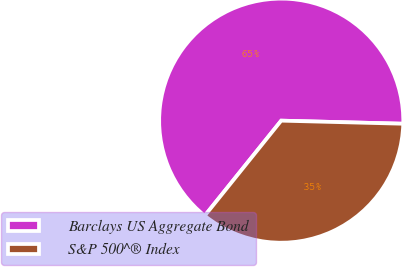Convert chart to OTSL. <chart><loc_0><loc_0><loc_500><loc_500><pie_chart><fcel>Barclays US Aggregate Bond<fcel>S&P 500^® Index<nl><fcel>64.62%<fcel>35.38%<nl></chart> 